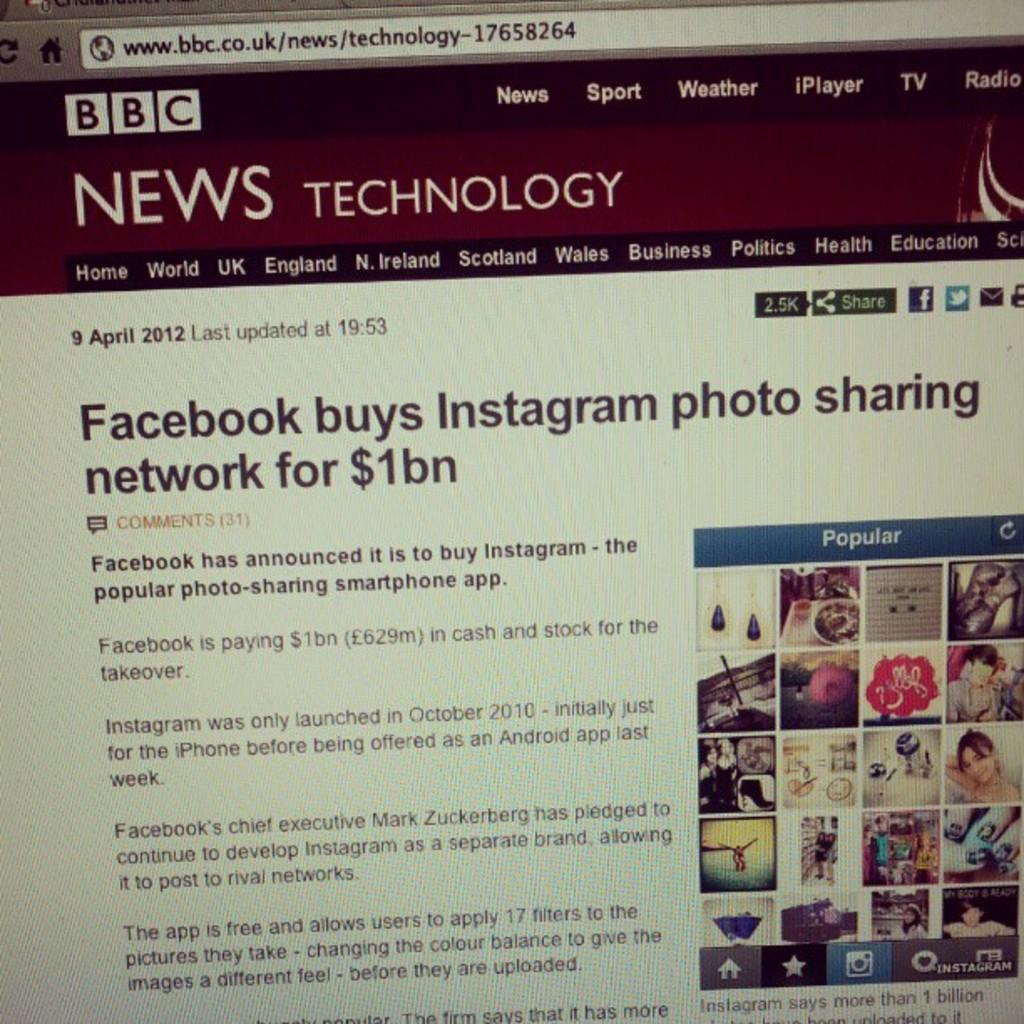<image>
Write a terse but informative summary of the picture. A web page for BBC news technology is displayed. 